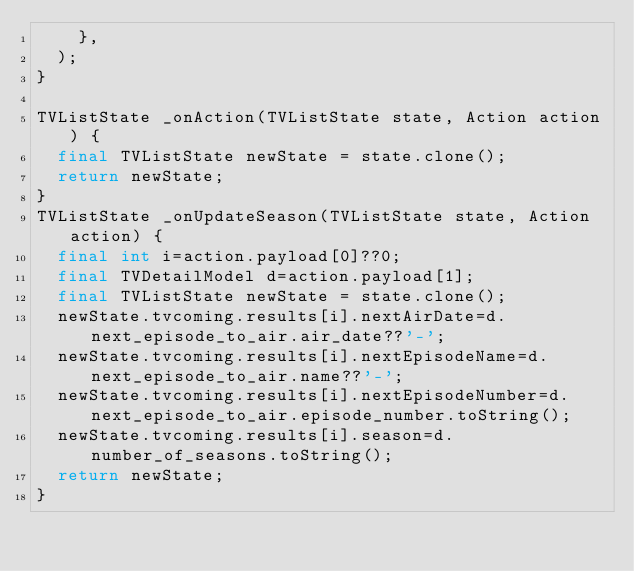<code> <loc_0><loc_0><loc_500><loc_500><_Dart_>    },
  );
}

TVListState _onAction(TVListState state, Action action) {
  final TVListState newState = state.clone();
  return newState;
}
TVListState _onUpdateSeason(TVListState state, Action action) {
  final int i=action.payload[0]??0;
  final TVDetailModel d=action.payload[1];
  final TVListState newState = state.clone();
  newState.tvcoming.results[i].nextAirDate=d.next_episode_to_air.air_date??'-';
  newState.tvcoming.results[i].nextEpisodeName=d.next_episode_to_air.name??'-';
  newState.tvcoming.results[i].nextEpisodeNumber=d.next_episode_to_air.episode_number.toString();
  newState.tvcoming.results[i].season=d.number_of_seasons.toString();
  return newState;
}
</code> 